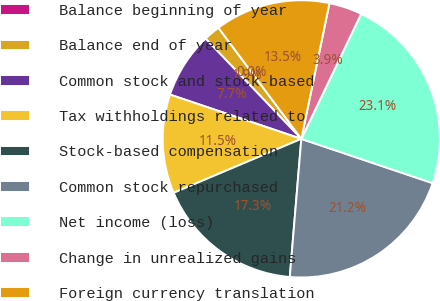<chart> <loc_0><loc_0><loc_500><loc_500><pie_chart><fcel>Balance beginning of year<fcel>Balance end of year<fcel>Common stock and stock-based<fcel>Tax withholdings related to<fcel>Stock-based compensation<fcel>Common stock repurchased<fcel>Net income (loss)<fcel>Change in unrealized gains<fcel>Foreign currency translation<nl><fcel>0.0%<fcel>1.93%<fcel>7.69%<fcel>11.54%<fcel>17.31%<fcel>21.15%<fcel>23.07%<fcel>3.85%<fcel>13.46%<nl></chart> 